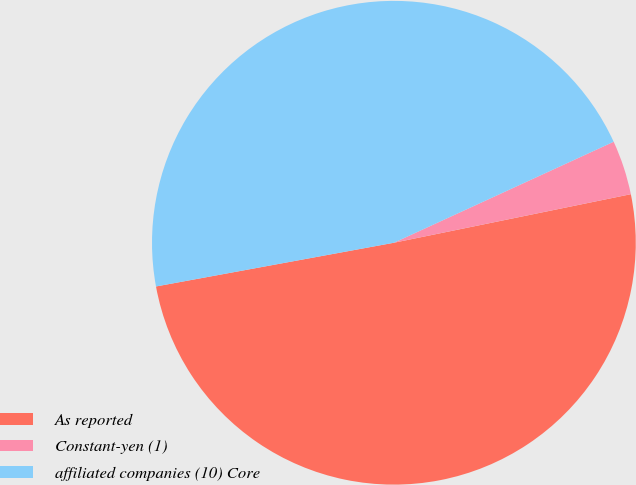<chart> <loc_0><loc_0><loc_500><loc_500><pie_chart><fcel>As reported<fcel>Constant-yen (1)<fcel>affiliated companies (10) Core<nl><fcel>50.33%<fcel>3.64%<fcel>46.04%<nl></chart> 